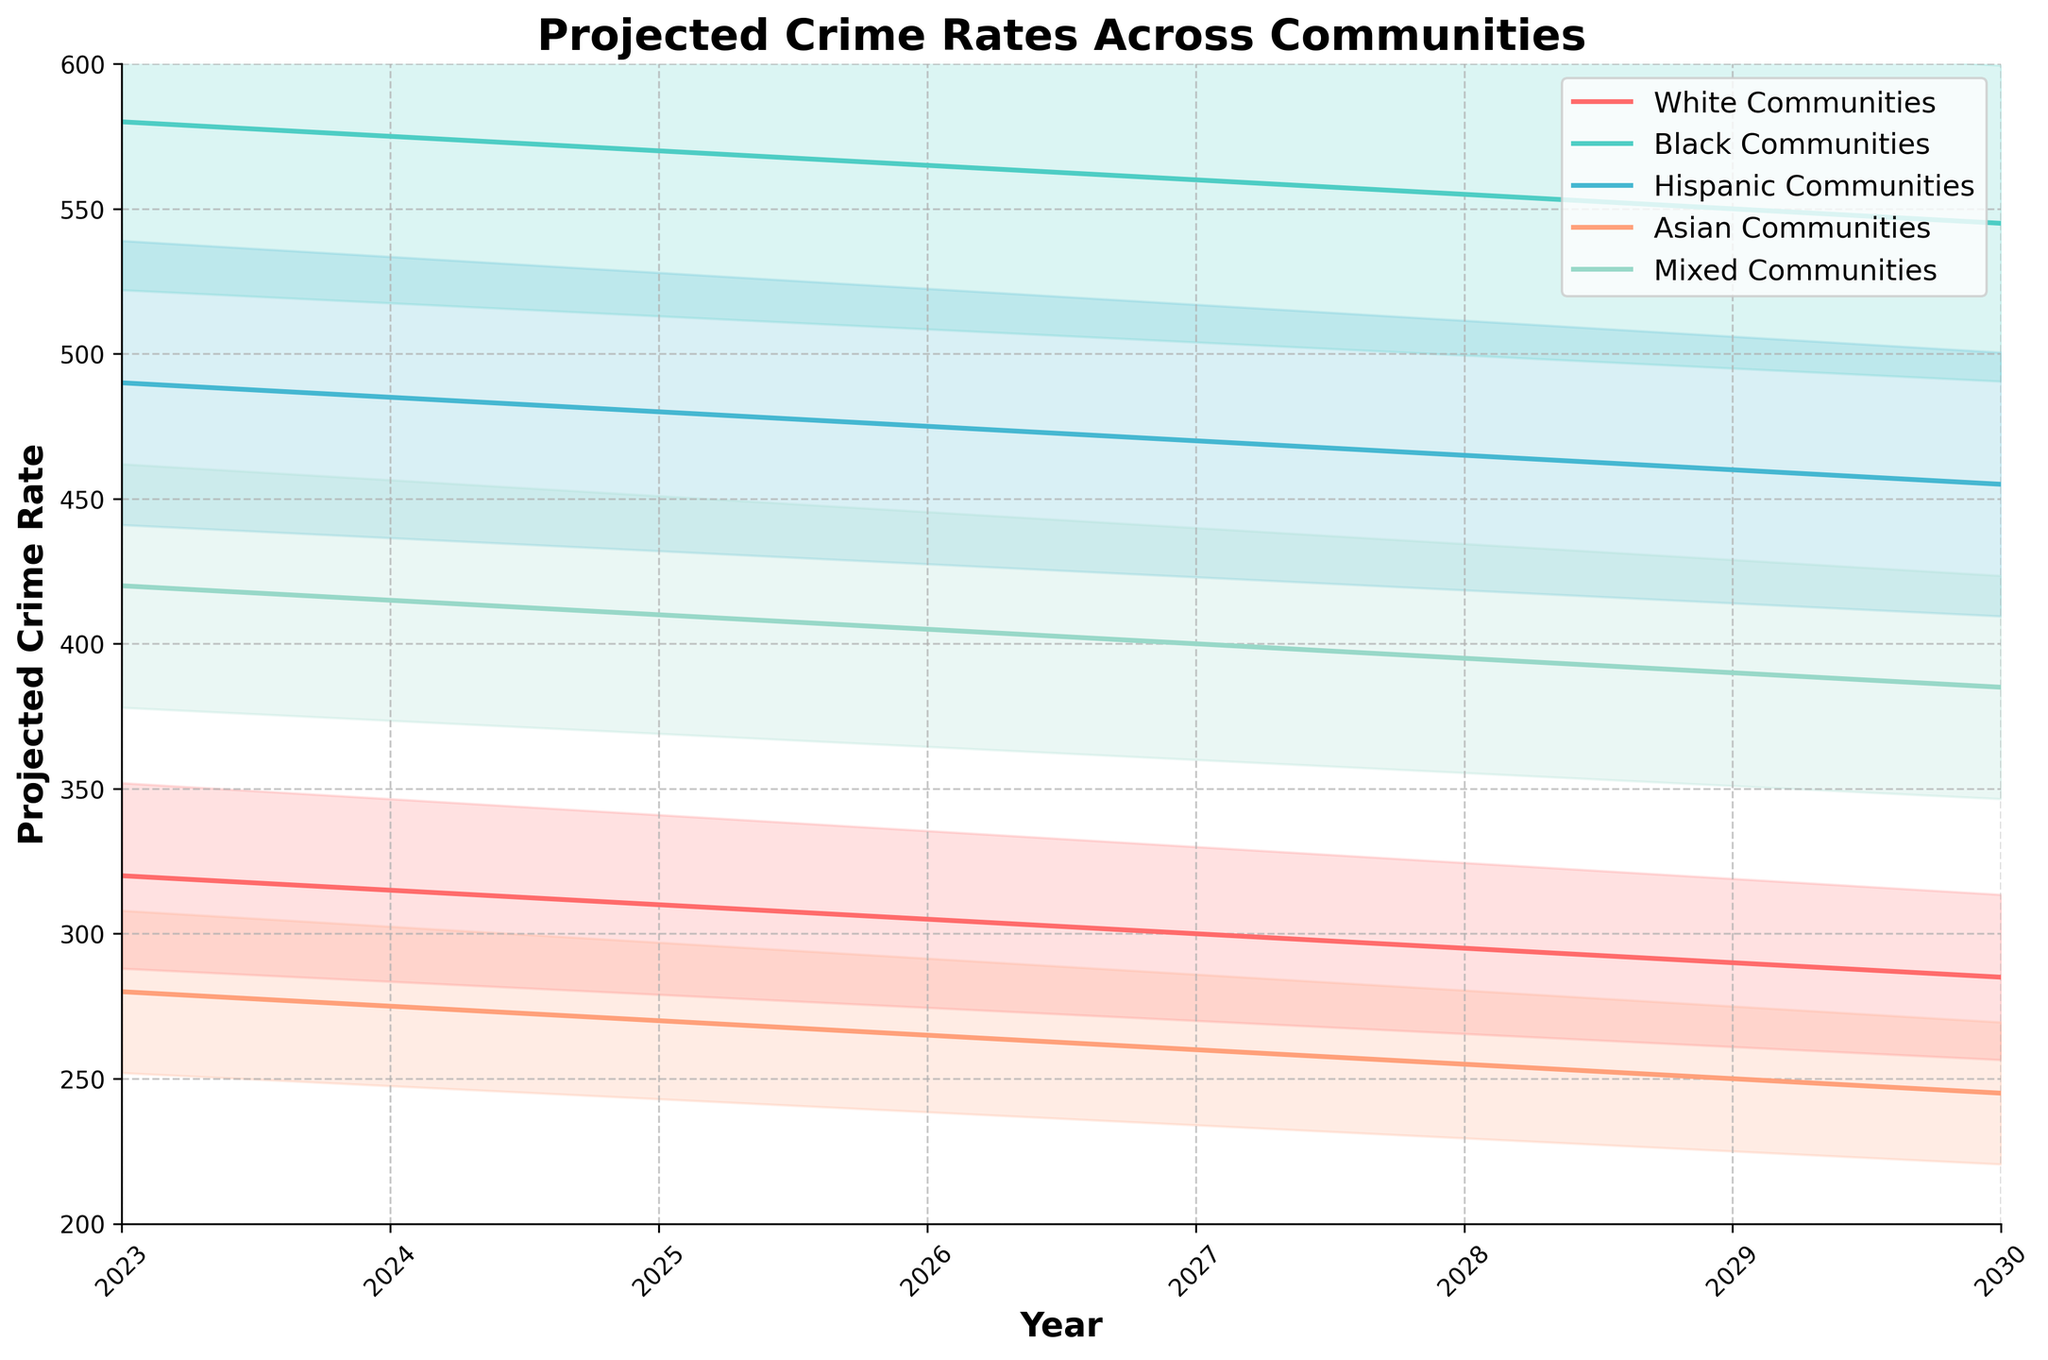What's the title of the chart? The chart title is located at the top of the figure, indicating what the chart is about.
Answer: Projected Crime Rates Across Communities How many communities are represented in the chart? Look at the legend on the top right of the chart or count the lines plotted.
Answer: Five Which community shows the highest crime rate in 2023? Refer to the y-axis values for each community above the year 2023. The community with the highest value is the highest.
Answer: Black Communities By how much is the projected crime rate for White Communities expected to decrease between 2023 and 2030? Find the crime rates for White Communities in 2023 and 2030 and subtract the latter from the former (320 - 285).
Answer: 35 Between which two consecutive years is the change in projected crime rate for Hispanic Communities the smallest? Calculate the differences for Hispanic Communities between consecutive years and identify the smallest difference. The changes are 490-485=5, 485-480=5, 480-475=5, etc.
Answer: 2024-2025 and 2025-2026 and 2026-2027 Which communities have overlapping projected crime rates in 2030? See which shaded areas (representing the fan effect) overlap in the year 2030. Heights of the shaded areas indicate potential ranges and overlaps.
Answer: Hispanic, Mixed, and Asian Communities What is the trend observed in the projected crime rates for all communities over the years? Look for the general direction of the lines across the years 2023 to 2030. All communities show a downward trend, indicating a decrease.
Answer: Decreasing What is the projected crime rate range for Black Communities in 2025? The fan effect shows the range from 570*0.9 to 570*1.1. Calculate these values: 513 to 627.
Answer: 513 to 627 Which community has the steepest projected decline in crime rate between 2023 and 2024? Calculate the difference in crime rates between 2023 and 2024 for all communities and find the largest difference: (580-575), (320-315), etc.
Answer: White Communities Are the projected crime rates for Asian Communities ever higher than those for Hispanic Communities between 2023 and 2030? Compare the crime rate values for Asian and Hispanic Communities over the years to see if Asian Communities' rates exceed those of Hispanic Communities at any point.
Answer: No 